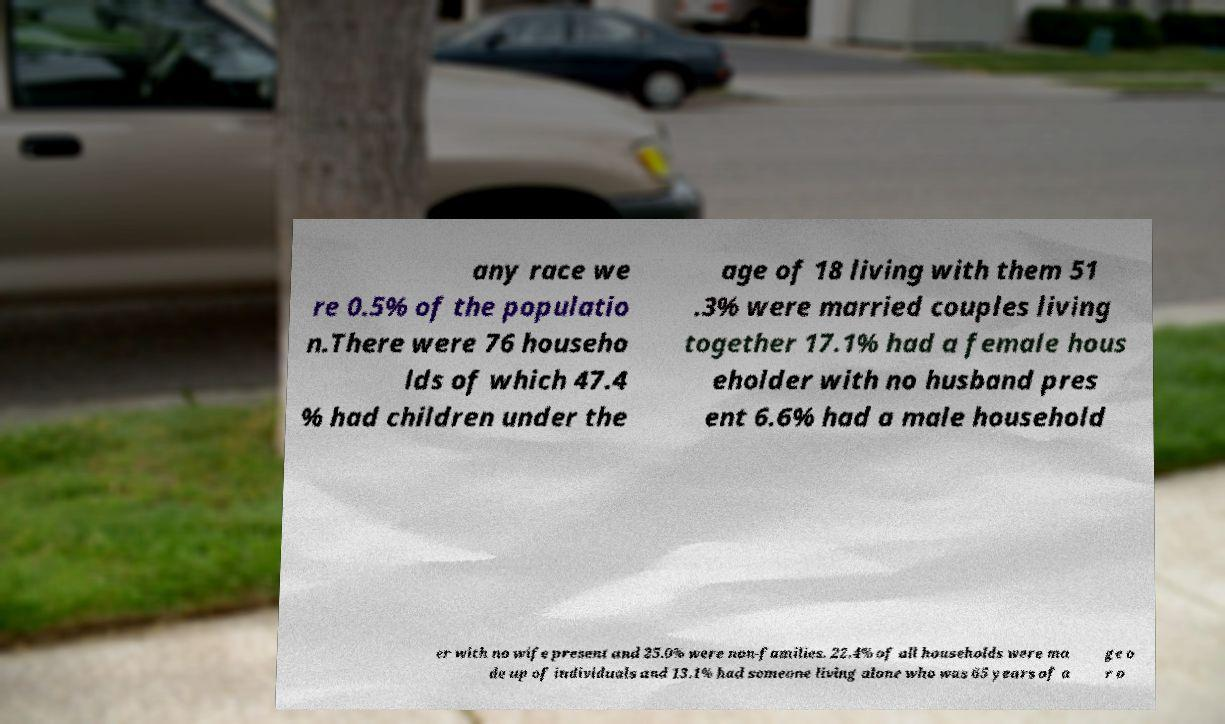What messages or text are displayed in this image? I need them in a readable, typed format. any race we re 0.5% of the populatio n.There were 76 househo lds of which 47.4 % had children under the age of 18 living with them 51 .3% were married couples living together 17.1% had a female hous eholder with no husband pres ent 6.6% had a male household er with no wife present and 25.0% were non-families. 22.4% of all households were ma de up of individuals and 13.1% had someone living alone who was 65 years of a ge o r o 